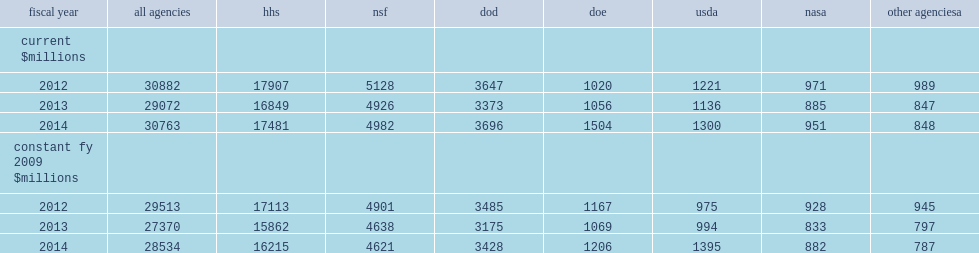How many percent did the department of health and human services (hhs), nsf, and the department of defense (dod) provide of all federally funded academic s&e obligations in fy 2014? 0.85034. How many percent did hhs account of all federally funded obligations? 0.568248. How many percent did nsf account of all federally funded obligations? 0.161948. How many percent did dod account of all federally funded obligations? 0.120144. 